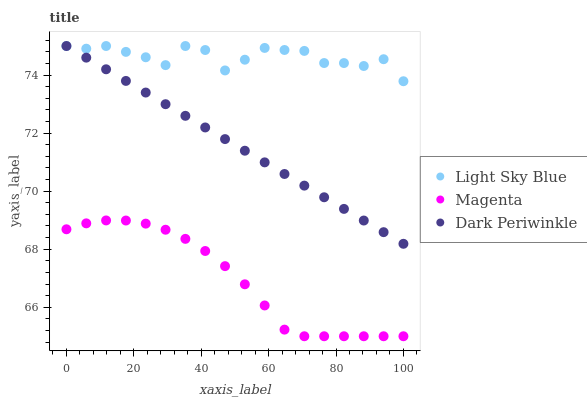Does Magenta have the minimum area under the curve?
Answer yes or no. Yes. Does Light Sky Blue have the maximum area under the curve?
Answer yes or no. Yes. Does Dark Periwinkle have the minimum area under the curve?
Answer yes or no. No. Does Dark Periwinkle have the maximum area under the curve?
Answer yes or no. No. Is Dark Periwinkle the smoothest?
Answer yes or no. Yes. Is Light Sky Blue the roughest?
Answer yes or no. Yes. Is Light Sky Blue the smoothest?
Answer yes or no. No. Is Dark Periwinkle the roughest?
Answer yes or no. No. Does Magenta have the lowest value?
Answer yes or no. Yes. Does Dark Periwinkle have the lowest value?
Answer yes or no. No. Does Dark Periwinkle have the highest value?
Answer yes or no. Yes. Is Magenta less than Dark Periwinkle?
Answer yes or no. Yes. Is Dark Periwinkle greater than Magenta?
Answer yes or no. Yes. Does Light Sky Blue intersect Dark Periwinkle?
Answer yes or no. Yes. Is Light Sky Blue less than Dark Periwinkle?
Answer yes or no. No. Is Light Sky Blue greater than Dark Periwinkle?
Answer yes or no. No. Does Magenta intersect Dark Periwinkle?
Answer yes or no. No. 